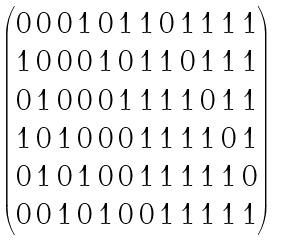<formula> <loc_0><loc_0><loc_500><loc_500>\begin{pmatrix} 0 \, 0 \, 0 \, 1 \, 0 \, 1 \, 1 \, 0 \, 1 \, 1 \, 1 \, 1 \\ 1 \, 0 \, 0 \, 0 \, 1 \, 0 \, 1 \, 1 \, 0 \, 1 \, 1 \, 1 \\ 0 \, 1 \, 0 \, 0 \, 0 \, 1 \, 1 \, 1 \, 1 \, 0 \, 1 \, 1 \\ 1 \, 0 \, 1 \, 0 \, 0 \, 0 \, 1 \, 1 \, 1 \, 1 \, 0 \, 1 \\ 0 \, 1 \, 0 \, 1 \, 0 \, 0 \, 1 \, 1 \, 1 \, 1 \, 1 \, 0 \\ 0 \, 0 \, 1 \, 0 \, 1 \, 0 \, 0 \, 1 \, 1 \, 1 \, 1 \, 1 \\ \end{pmatrix}</formula> 